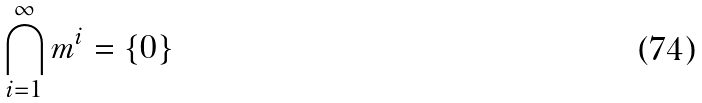Convert formula to latex. <formula><loc_0><loc_0><loc_500><loc_500>\bigcap _ { i = 1 } ^ { \infty } m ^ { i } = \{ 0 \}</formula> 